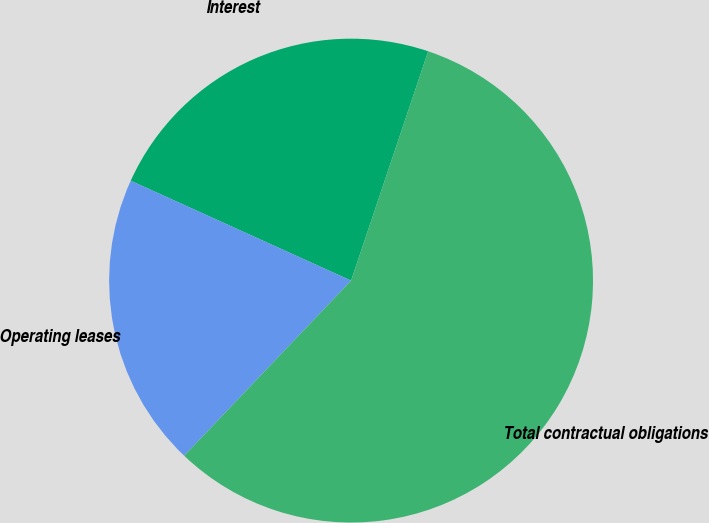<chart> <loc_0><loc_0><loc_500><loc_500><pie_chart><fcel>Interest<fcel>Operating leases<fcel>Total contractual obligations<nl><fcel>23.39%<fcel>19.66%<fcel>56.95%<nl></chart> 